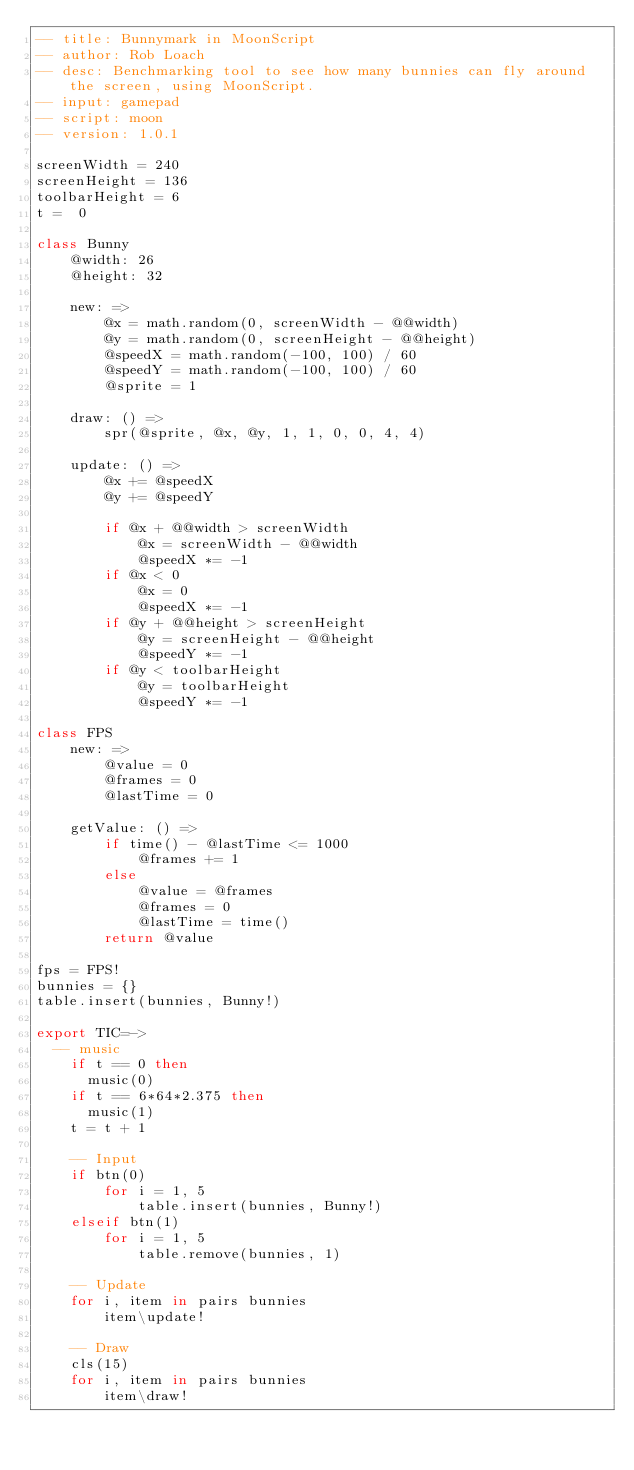Convert code to text. <code><loc_0><loc_0><loc_500><loc_500><_MoonScript_>-- title: Bunnymark in MoonScript
-- author: Rob Loach
-- desc: Benchmarking tool to see how many bunnies can fly around the screen, using MoonScript.
-- input: gamepad
-- script: moon
-- version: 1.0.1

screenWidth = 240
screenHeight = 136
toolbarHeight = 6
t =  0

class Bunny
	@width: 26
	@height: 32

	new: =>
		@x = math.random(0, screenWidth - @@width)
		@y = math.random(0, screenHeight - @@height)
		@speedX = math.random(-100, 100) / 60
		@speedY = math.random(-100, 100) / 60
		@sprite = 1

	draw: () =>
		spr(@sprite, @x, @y, 1, 1, 0, 0, 4, 4)

	update: () =>
		@x += @speedX
		@y += @speedY

		if @x + @@width > screenWidth
			@x = screenWidth - @@width
			@speedX *= -1
		if @x < 0
			@x = 0
			@speedX *= -1
		if @y + @@height > screenHeight
			@y = screenHeight - @@height
			@speedY *= -1
		if @y < toolbarHeight
			@y = toolbarHeight
			@speedY *= -1

class FPS
	new: =>
		@value = 0
		@frames = 0
		@lastTime = 0

	getValue: () =>
		if time() - @lastTime <= 1000
			@frames += 1
		else
			@value = @frames
			@frames = 0
			@lastTime = time()
		return @value

fps = FPS!
bunnies = {}
table.insert(bunnies, Bunny!)

export TIC=->
  -- music
	if t == 0 then
	  music(0)
	if t == 6*64*2.375 then
	  music(1)
	t = t + 1

	-- Input
	if btn(0)
		for i = 1, 5
			table.insert(bunnies, Bunny!)
	elseif btn(1)
		for i = 1, 5
			table.remove(bunnies, 1)

	-- Update
	for i, item in pairs bunnies
		item\update!

	-- Draw
	cls(15)
	for i, item in pairs bunnies
		item\draw!
</code> 